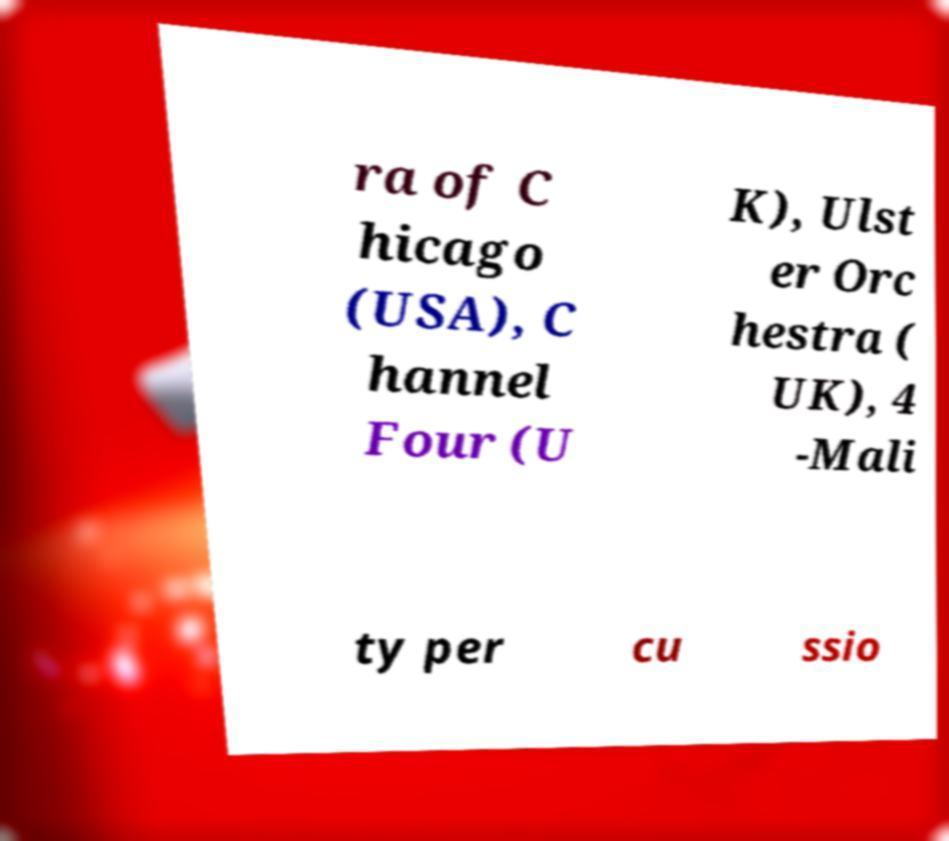What messages or text are displayed in this image? I need them in a readable, typed format. ra of C hicago (USA), C hannel Four (U K), Ulst er Orc hestra ( UK), 4 -Mali ty per cu ssio 